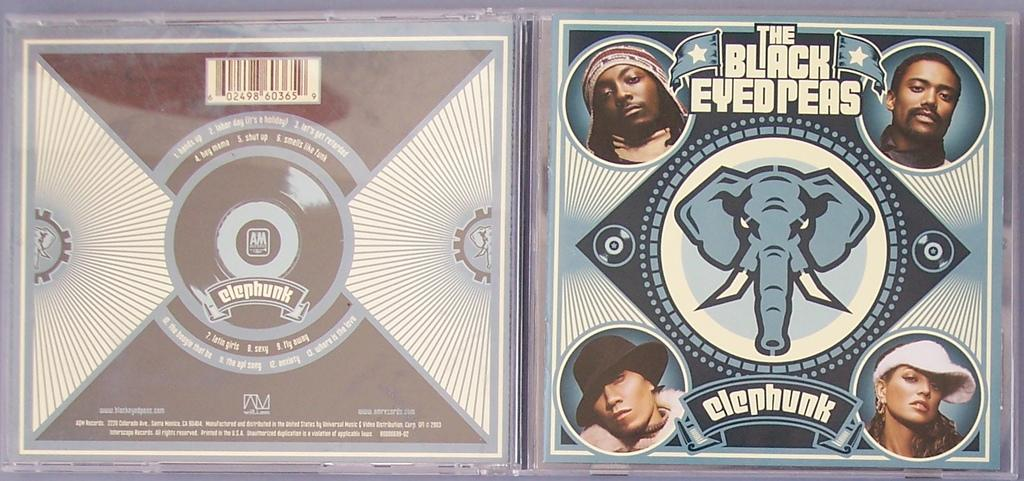What is present in the image? There is a poster in the image. What can be seen on the poster? The poster contains pictures of people and text. What advice can be found on the poster in the image? There is no advice present on the poster in the image; it only contains pictures of people and text. 